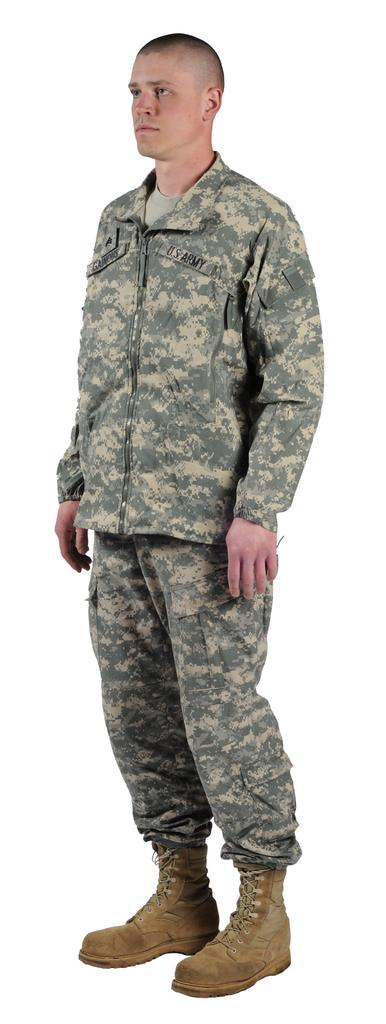Who is present in the image? There is a man in the image. What is the man wearing? The man is wearing a uniform and shoes. In which direction is the man facing? The man is standing facing towards the left side. What is the color of the background in the image? The background of the image is white. What type of nose can be seen on the yam in the image? There is no yam present in the image, and therefore no nose can be seen on it. 